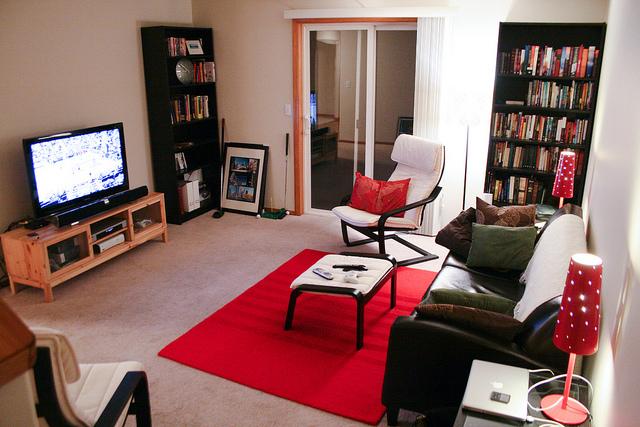Is this a private home?
Answer briefly. Yes. Where are the books?
Concise answer only. Bookshelf. Is the television a flat screen?
Quick response, please. Yes. How many objects are sitting on the TV stand?
Quick response, please. 2. Does the carpet match the lamps?
Give a very brief answer. Yes. 